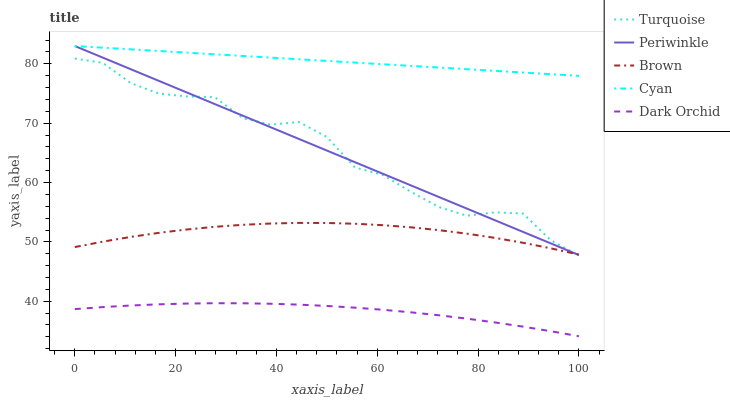Does Dark Orchid have the minimum area under the curve?
Answer yes or no. Yes. Does Cyan have the maximum area under the curve?
Answer yes or no. Yes. Does Turquoise have the minimum area under the curve?
Answer yes or no. No. Does Turquoise have the maximum area under the curve?
Answer yes or no. No. Is Periwinkle the smoothest?
Answer yes or no. Yes. Is Turquoise the roughest?
Answer yes or no. Yes. Is Turquoise the smoothest?
Answer yes or no. No. Is Periwinkle the roughest?
Answer yes or no. No. Does Turquoise have the lowest value?
Answer yes or no. No. Does Turquoise have the highest value?
Answer yes or no. No. Is Dark Orchid less than Brown?
Answer yes or no. Yes. Is Periwinkle greater than Dark Orchid?
Answer yes or no. Yes. Does Dark Orchid intersect Brown?
Answer yes or no. No. 